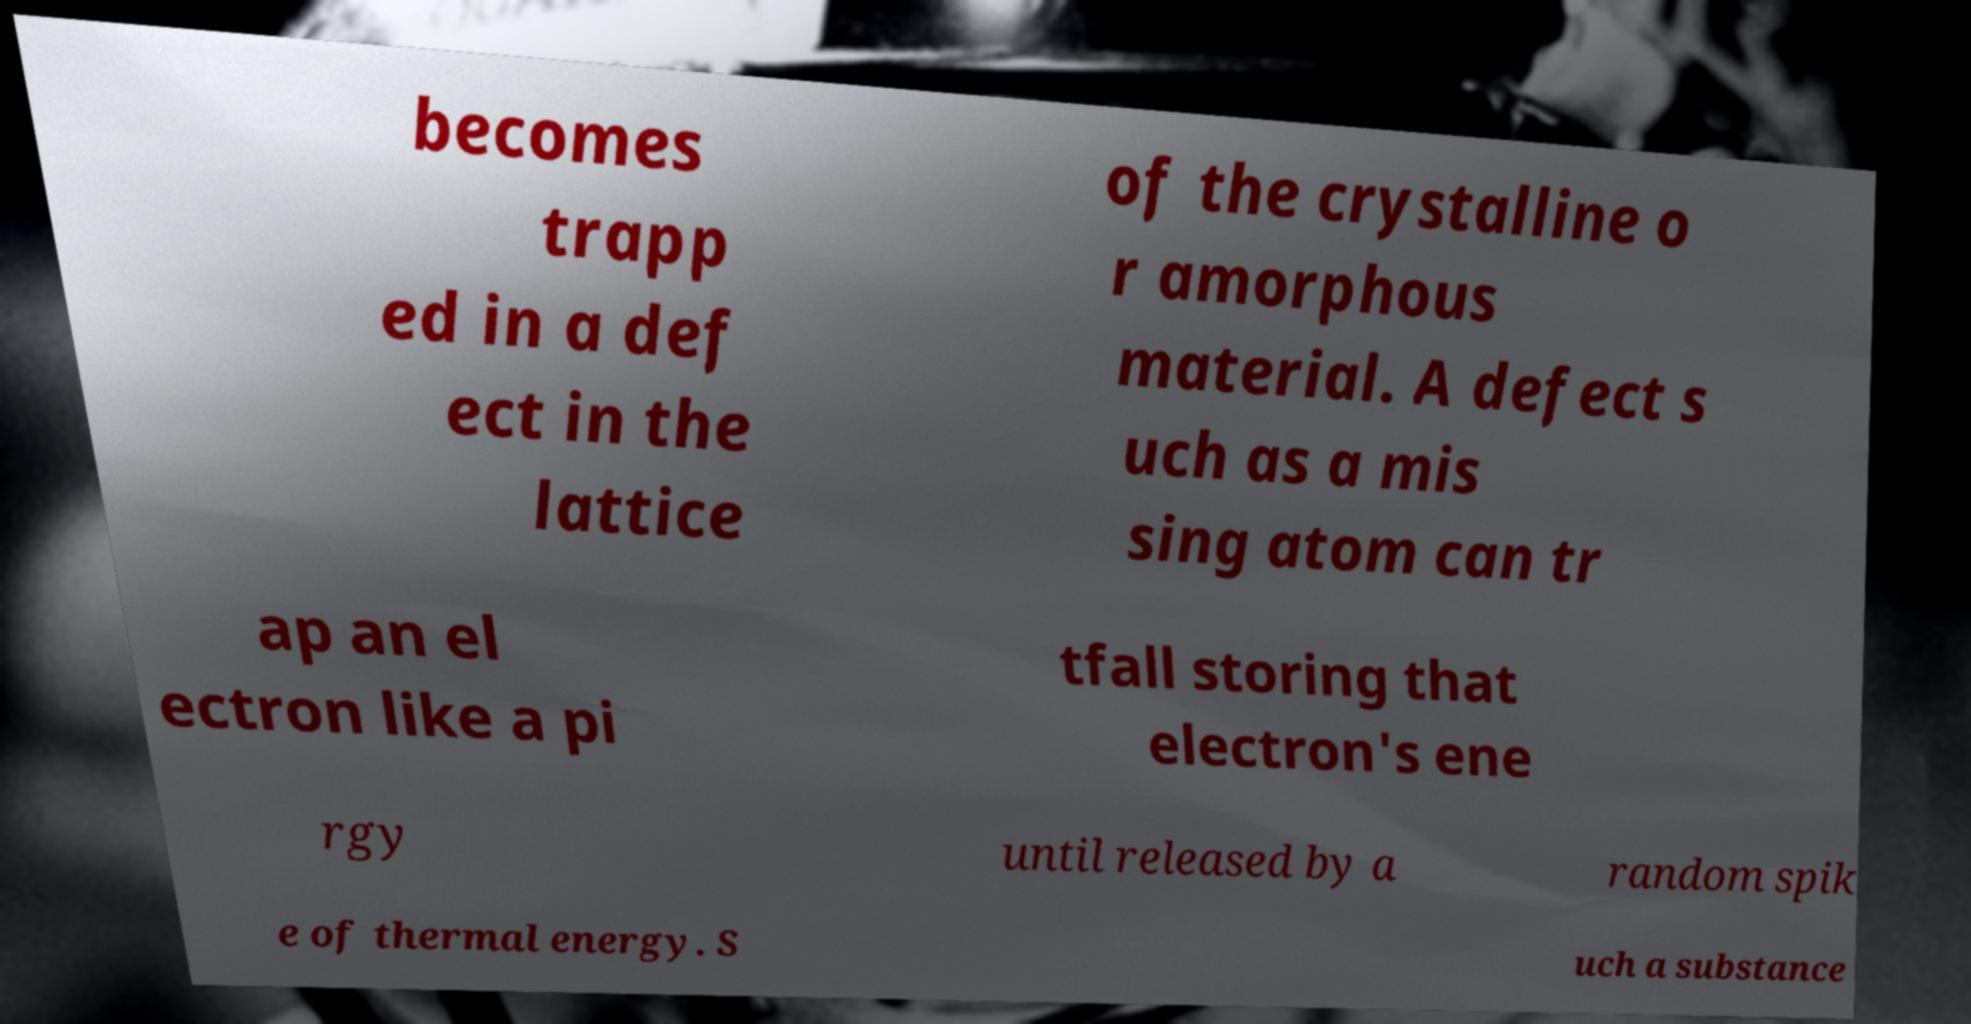What messages or text are displayed in this image? I need them in a readable, typed format. becomes trapp ed in a def ect in the lattice of the crystalline o r amorphous material. A defect s uch as a mis sing atom can tr ap an el ectron like a pi tfall storing that electron's ene rgy until released by a random spik e of thermal energy. S uch a substance 